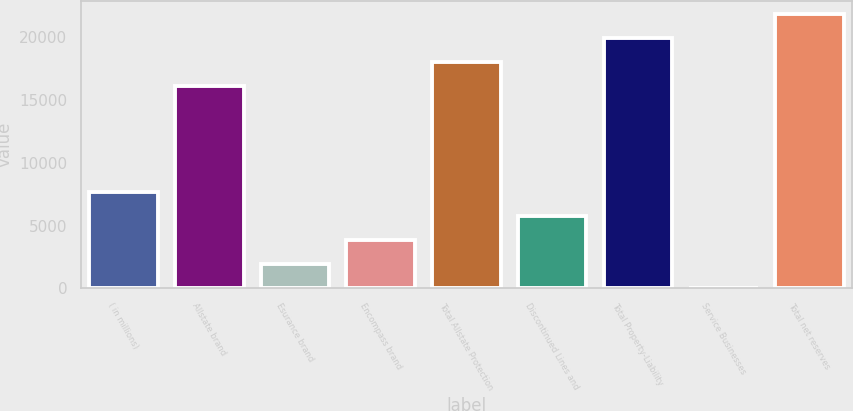Convert chart. <chart><loc_0><loc_0><loc_500><loc_500><bar_chart><fcel>( in millions)<fcel>Allstate brand<fcel>Esurance brand<fcel>Encompass brand<fcel>Total Allstate Protection<fcel>Discontinued Lines and<fcel>Total Property-Liability<fcel>Service Businesses<fcel>Total net reserves<nl><fcel>7640.8<fcel>16108<fcel>1928.2<fcel>3832.4<fcel>18012.2<fcel>5736.6<fcel>19916.4<fcel>24<fcel>21820.6<nl></chart> 